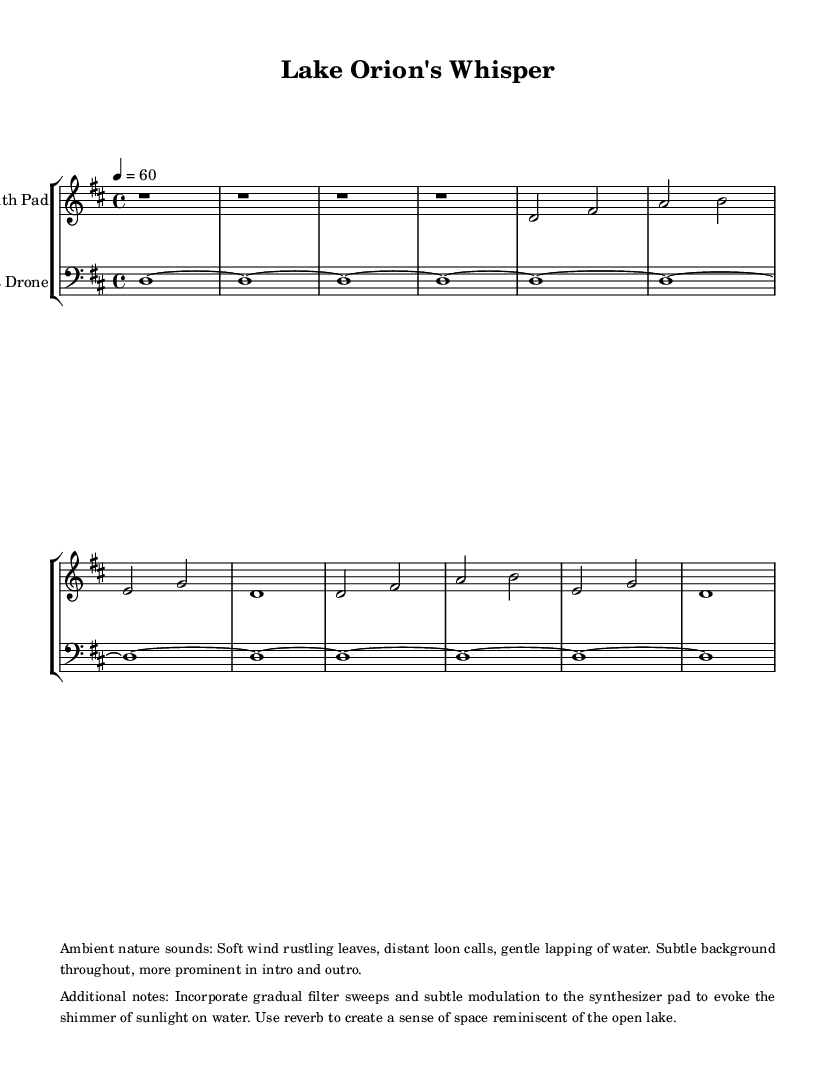What is the key signature of this music? The key signature is indicated by the sharps or flats at the beginning of the staff, and in this case, it shows two sharps on the staff lines, which denote D major.
Answer: D major What is the time signature of this piece? The time signature is indicated at the beginning of the staff in the form of a fraction, and here it is represented as 4 over 4, meaning there are four beats in each measure.
Answer: 4/4 What tempo is indicated for this music? The tempo is shown above the staff with a numerical value and a symbol "=," specifying the beats per minute. Here, it shows "4 = 60," indicating a slow tempo of 60 beats per minute.
Answer: 60 How many measures are indicated in this piece? By counting the number of vertical lines that separate the different sections of music on the staff, we can see there are 8 measures present total in the given score.
Answer: 8 What instruments are featured in this score? The instruments are labeled at the beginning of each staff indicating the parts being played, which are "Synth Pad" for the treble clef and "Bass Drone" for the bass clef.
Answer: Synth Pad and Bass Drone What unique sound elements are indicated in this piece? The ambient nature sounds are described in the markup section, which suggests incorporating soft wind, distant loon calls, and gentle lapping of water as integral to the composition.
Answer: Nature sounds What musical technique is suggested to evoke sunlight on water? In the additional notes mentioned, it specifies the use of gradual filter sweeps and subtle modulation applied to the synthesizer to create a shimmering effect, mimicking sunlight on the water.
Answer: Filter sweeps and modulation 